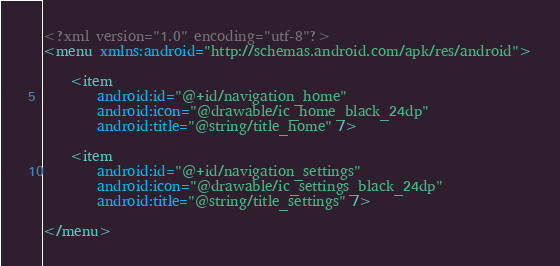<code> <loc_0><loc_0><loc_500><loc_500><_XML_><?xml version="1.0" encoding="utf-8"?>
<menu xmlns:android="http://schemas.android.com/apk/res/android">

    <item
        android:id="@+id/navigation_home"
        android:icon="@drawable/ic_home_black_24dp"
        android:title="@string/title_home" />

    <item
        android:id="@+id/navigation_settings"
        android:icon="@drawable/ic_settings_black_24dp"
        android:title="@string/title_settings" />

</menu>
</code> 